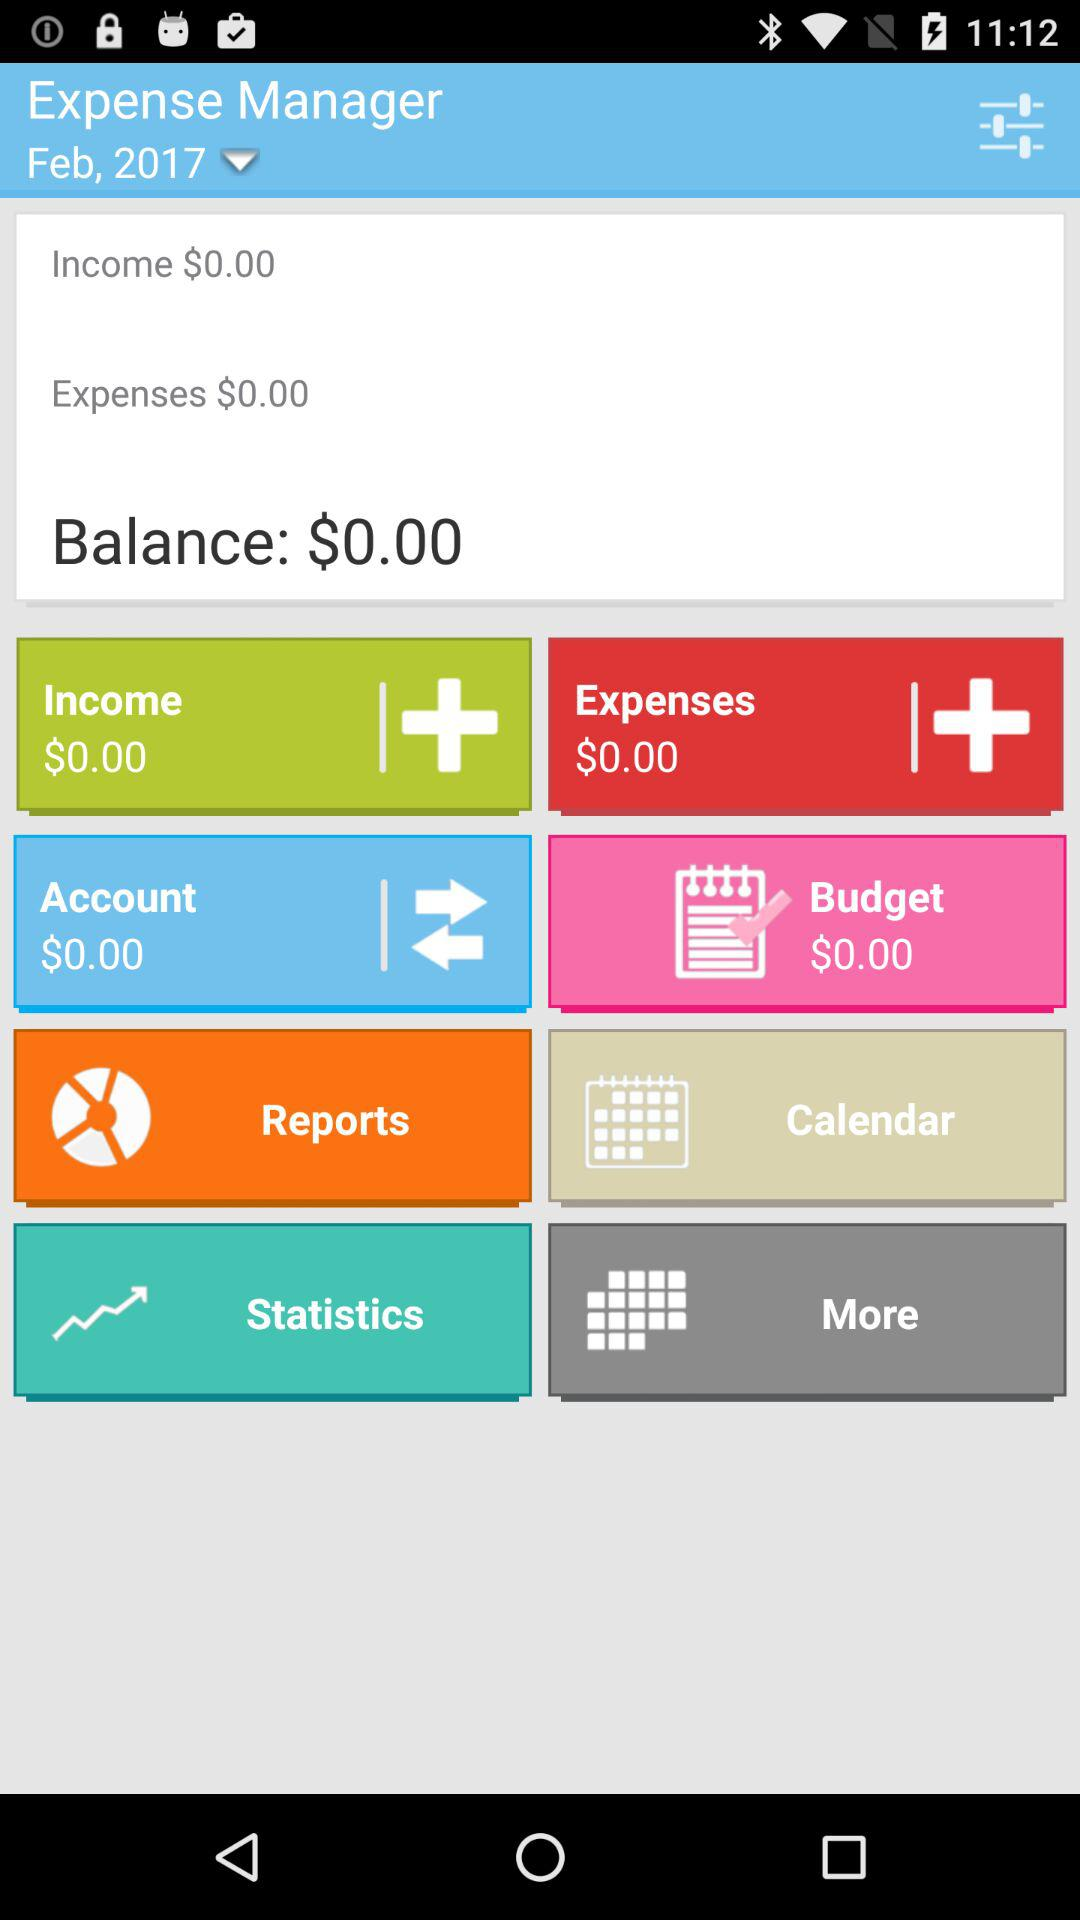What is the name of the application? The name of the application is "Expense Manager". 